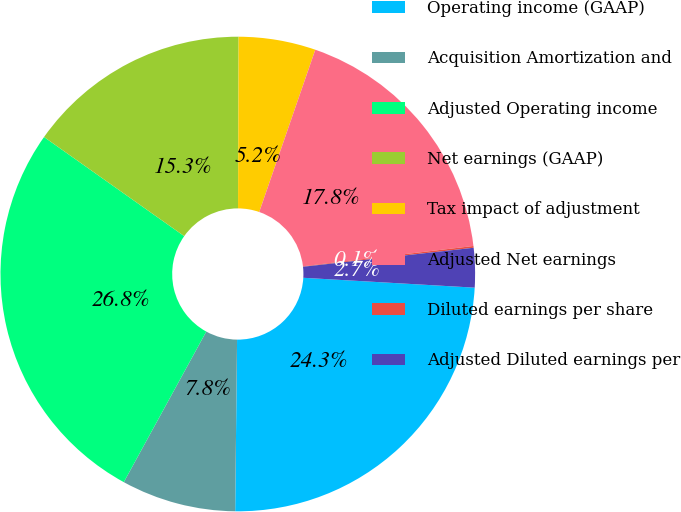<chart> <loc_0><loc_0><loc_500><loc_500><pie_chart><fcel>Operating income (GAAP)<fcel>Acquisition Amortization and<fcel>Adjusted Operating income<fcel>Net earnings (GAAP)<fcel>Tax impact of adjustment<fcel>Adjusted Net earnings<fcel>Diluted earnings per share<fcel>Adjusted Diluted earnings per<nl><fcel>24.26%<fcel>7.8%<fcel>26.82%<fcel>15.26%<fcel>5.24%<fcel>17.82%<fcel>0.12%<fcel>2.68%<nl></chart> 